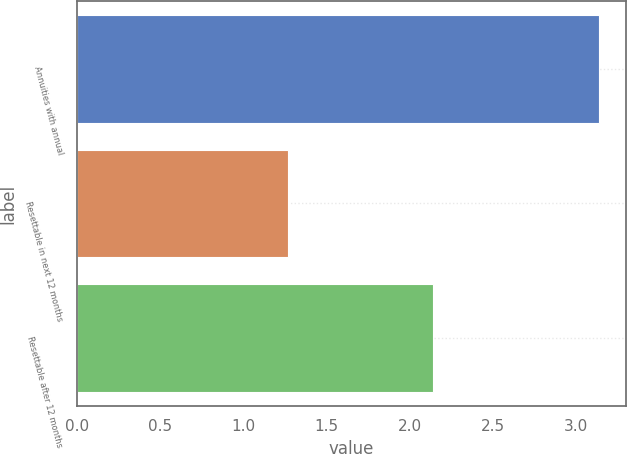Convert chart to OTSL. <chart><loc_0><loc_0><loc_500><loc_500><bar_chart><fcel>Annuities with annual<fcel>Resettable in next 12 months<fcel>Resettable after 12 months<nl><fcel>3.14<fcel>1.27<fcel>2.14<nl></chart> 